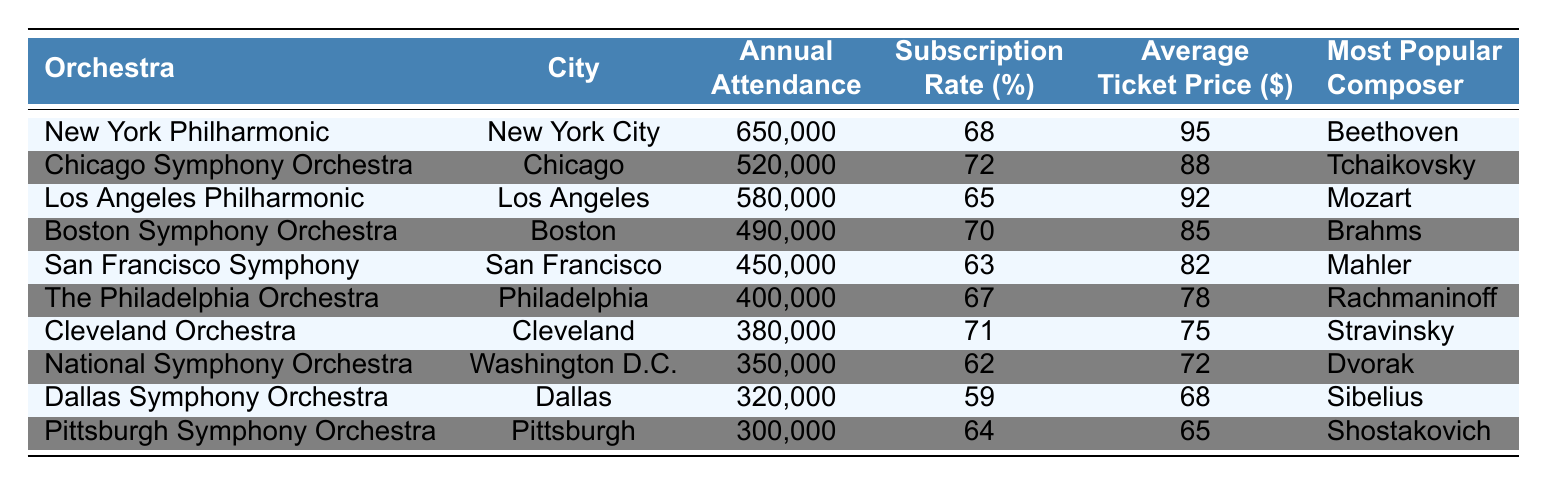What is the annual attendance of the New York Philharmonic? By looking at the row corresponding to the New York Philharmonic, the annual attendance is listed under the "Annual Attendance" column. It shows 650,000.
Answer: 650,000 Which orchestra has the highest subscription rate? Scanning down the "Subscription Rate (%)" column, the highest value is 72%, which corresponds to the Chicago Symphony Orchestra.
Answer: Chicago Symphony Orchestra What is the average ticket price for the Boston Symphony Orchestra? To find this, refer to the row for the Boston Symphony Orchestra in the "Average Ticket Price ($)" column, which shows a price of 85.
Answer: 85 How many orchestras have an annual attendance of over 500,000? Count the rows where the "Annual Attendance" exceeds 500,000. The New York Philharmonic (650,000), Los Angeles Philharmonic (580,000), and Chicago Symphony Orchestra (520,000) meet this criterion, totaling 3 orchestras.
Answer: 3 What is the most popular composer for the Philadelphia Orchestra? Look in the "Most Popular Composer" column for the row corresponding to the Philadelphia Orchestra. It lists Rachmaninoff as the most popular composer.
Answer: Rachmaninoff Is the average ticket price of the Cleveland Orchestra less than $80? The average ticket price for the Cleveland Orchestra is listed as 75. Since 75 is less than 80, the answer is yes.
Answer: Yes Which city has an orchestra with the lowest annual attendance? The lowest annual attendance is for the Pittsburgh Symphony Orchestra at 300,000, which is located in Pittsburgh.
Answer: Pittsburgh Calculate the difference in average ticket price between the New York Philharmonic and the Dallas Symphony Orchestra. The average ticket price for the New York Philharmonic is 95, and for the Dallas Symphony Orchestra, it is 68. The difference is 95 - 68 = 27.
Answer: 27 What is the most popular composer of orchestras with an annual attendance below 400,000? The orchestras with an attendance below 400,000 are the Philadelphia Orchestra (400,000), Cleveland Orchestra (380,000), National Symphony Orchestra (350,000), Dallas Symphony Orchestra (320,000), and Pittsburgh Symphony Orchestra (300,000). They correspond to Rachmaninoff, Stravinsky, Dvorak, Sibelius, and Shostakovich respectively. The most popular from this list is Rachmaninoff.
Answer: Rachmaninoff Which orchestra has a higher subscription rate, the San Francisco Symphony or the Los Angeles Philharmonic? The subscription rate for the San Francisco Symphony is 63%, while for the Los Angeles Philharmonic, it is 65%. Since 65% is greater than 63%, the Los Angeles Philharmonic has a higher rate.
Answer: Los Angeles Philharmonic 